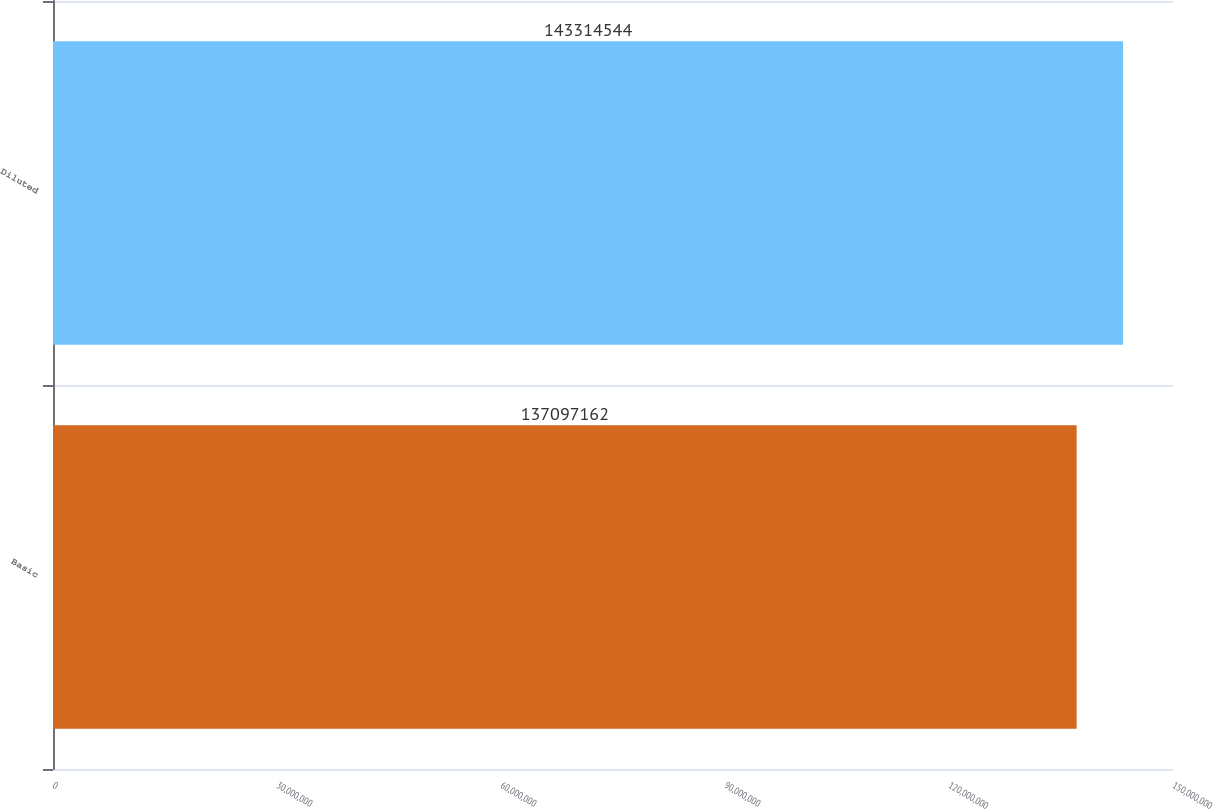Convert chart to OTSL. <chart><loc_0><loc_0><loc_500><loc_500><bar_chart><fcel>Basic<fcel>Diluted<nl><fcel>1.37097e+08<fcel>1.43315e+08<nl></chart> 